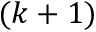Convert formula to latex. <formula><loc_0><loc_0><loc_500><loc_500>( k + 1 )</formula> 